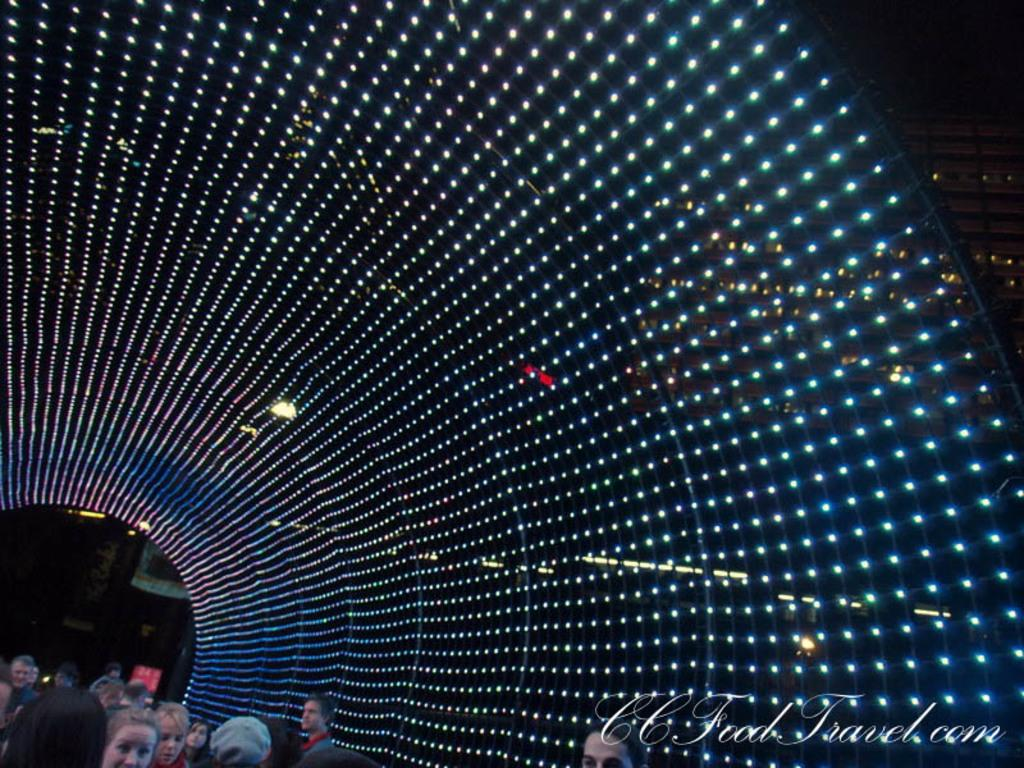How many people are in the image? There is a group of people in the image. What can be seen in the image besides the people? There are lights visible in the image, as well as a building on the right side. Is there any text present in the image? Yes, there is some text in the bottom right-hand corner of the image. How many pairs of shoes are visible in the image? There is no mention of shoes in the image, so it is not possible to determine how many pairs are visible. 